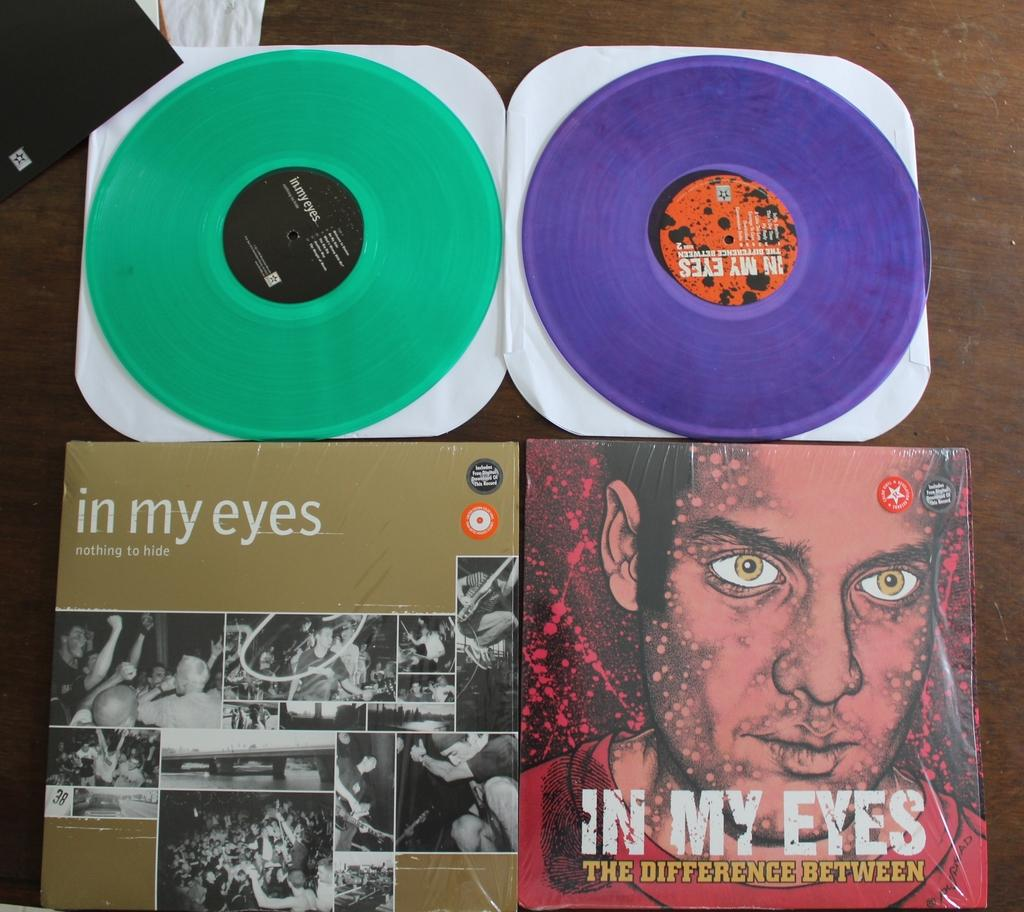What objects are located at the bottom of the image? There are boxes at the bottom of the image. What can be seen at the top of the image? There is DJ material at the top of the image. What type of can is visible in the image? There is no can present in the image. What is the texture of the DJ material in the image? The provided facts do not mention the texture of the DJ material, so it cannot be determined from the image. 